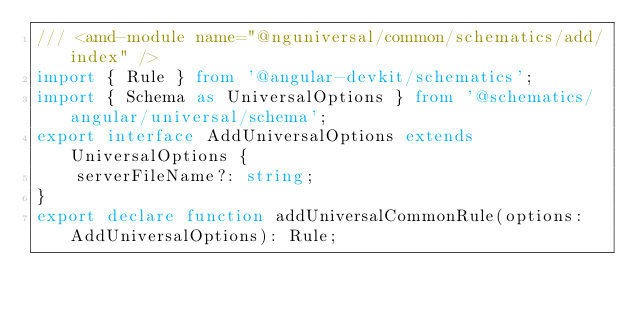Convert code to text. <code><loc_0><loc_0><loc_500><loc_500><_TypeScript_>/// <amd-module name="@nguniversal/common/schematics/add/index" />
import { Rule } from '@angular-devkit/schematics';
import { Schema as UniversalOptions } from '@schematics/angular/universal/schema';
export interface AddUniversalOptions extends UniversalOptions {
    serverFileName?: string;
}
export declare function addUniversalCommonRule(options: AddUniversalOptions): Rule;
</code> 